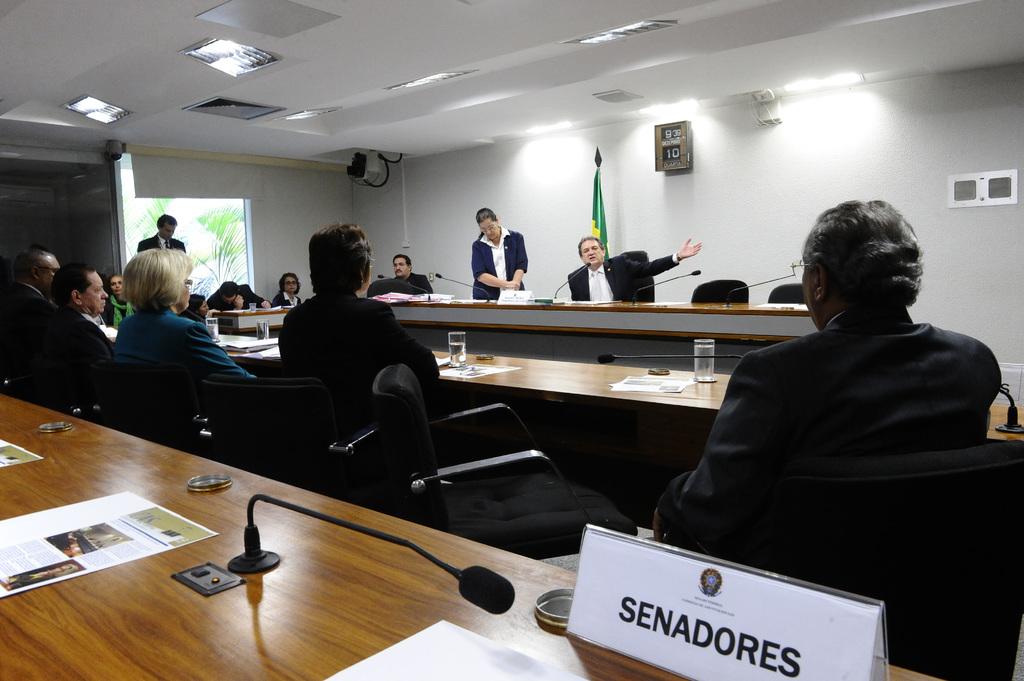What is the name on the desk?
Your answer should be compact. Senadores. What is written above the name on the desk?
Give a very brief answer. Senadores. 